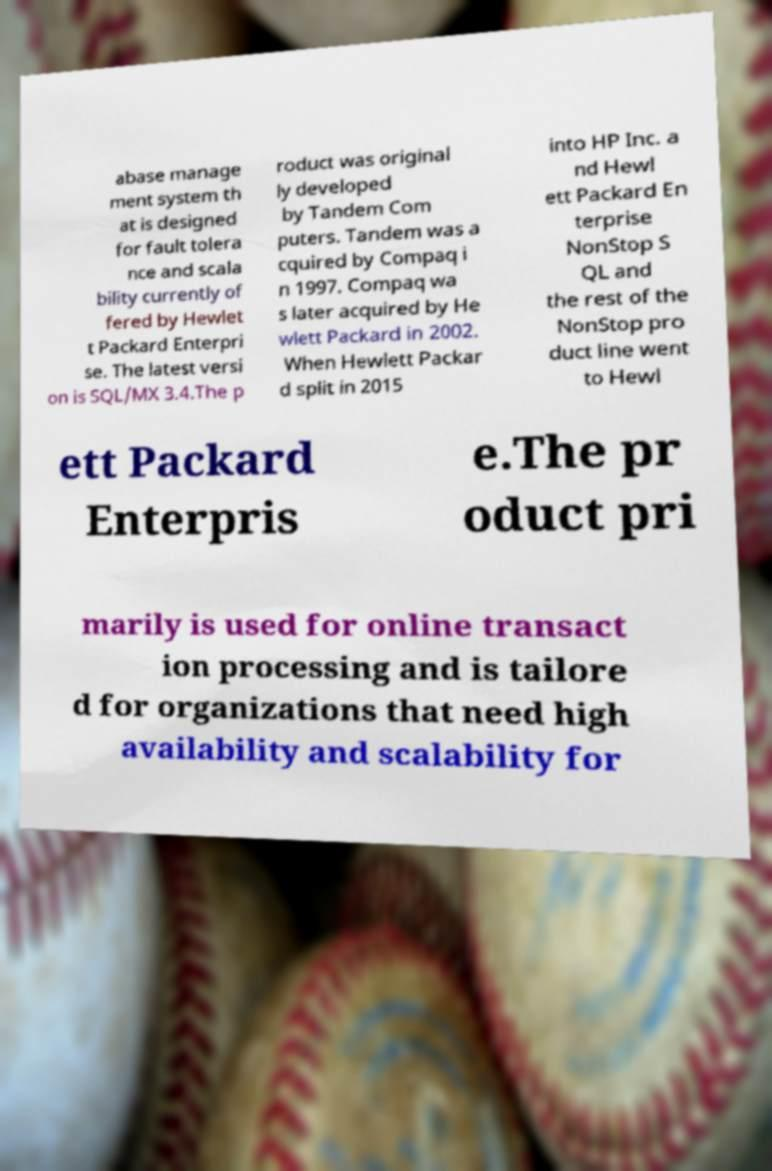What messages or text are displayed in this image? I need them in a readable, typed format. abase manage ment system th at is designed for fault tolera nce and scala bility currently of fered by Hewlet t Packard Enterpri se. The latest versi on is SQL/MX 3.4.The p roduct was original ly developed by Tandem Com puters. Tandem was a cquired by Compaq i n 1997. Compaq wa s later acquired by He wlett Packard in 2002. When Hewlett Packar d split in 2015 into HP Inc. a nd Hewl ett Packard En terprise NonStop S QL and the rest of the NonStop pro duct line went to Hewl ett Packard Enterpris e.The pr oduct pri marily is used for online transact ion processing and is tailore d for organizations that need high availability and scalability for 